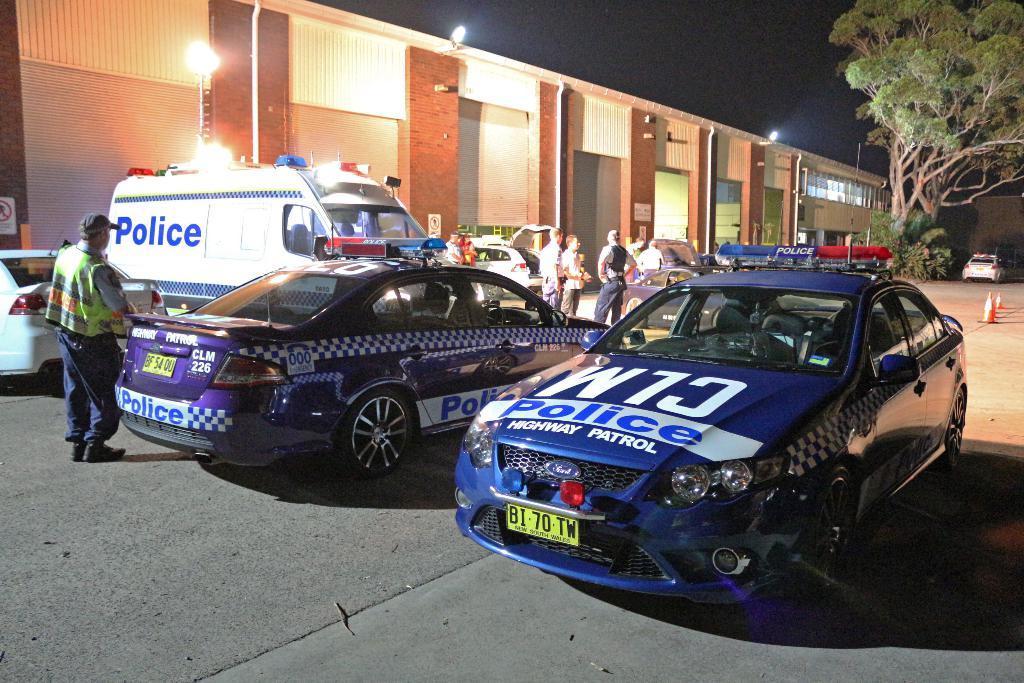How would you summarize this image in a sentence or two? This is the picture of a place where we have a house to which there are some lights and around there are some cars, people and some trees. 